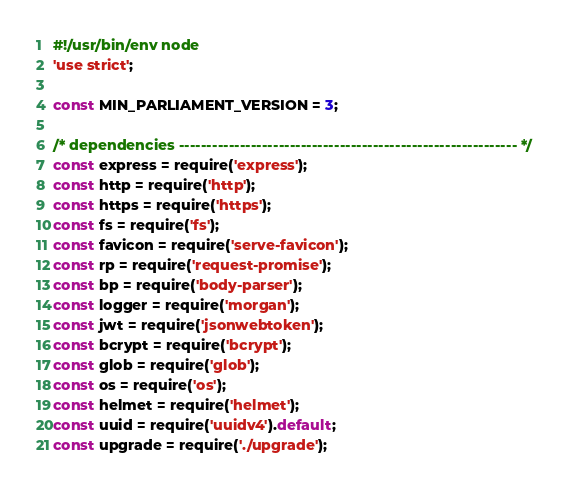Convert code to text. <code><loc_0><loc_0><loc_500><loc_500><_JavaScript_>#!/usr/bin/env node
'use strict';

const MIN_PARLIAMENT_VERSION = 3;

/* dependencies ------------------------------------------------------------- */
const express = require('express');
const http = require('http');
const https = require('https');
const fs = require('fs');
const favicon = require('serve-favicon');
const rp = require('request-promise');
const bp = require('body-parser');
const logger = require('morgan');
const jwt = require('jsonwebtoken');
const bcrypt = require('bcrypt');
const glob = require('glob');
const os = require('os');
const helmet = require('helmet');
const uuid = require('uuidv4').default;
const upgrade = require('./upgrade');</code> 